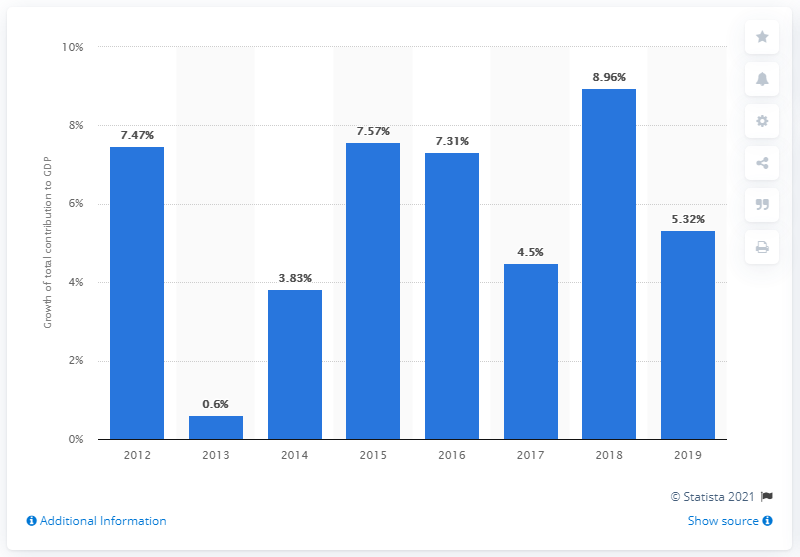Identify some key points in this picture. In 2019, the total contribution of travel and tourism to the Gross Domestic Product (GDP) grew by 5.32%. This indicates that the travel and tourism industry had a positive impact on the overall economic growth of the country. 